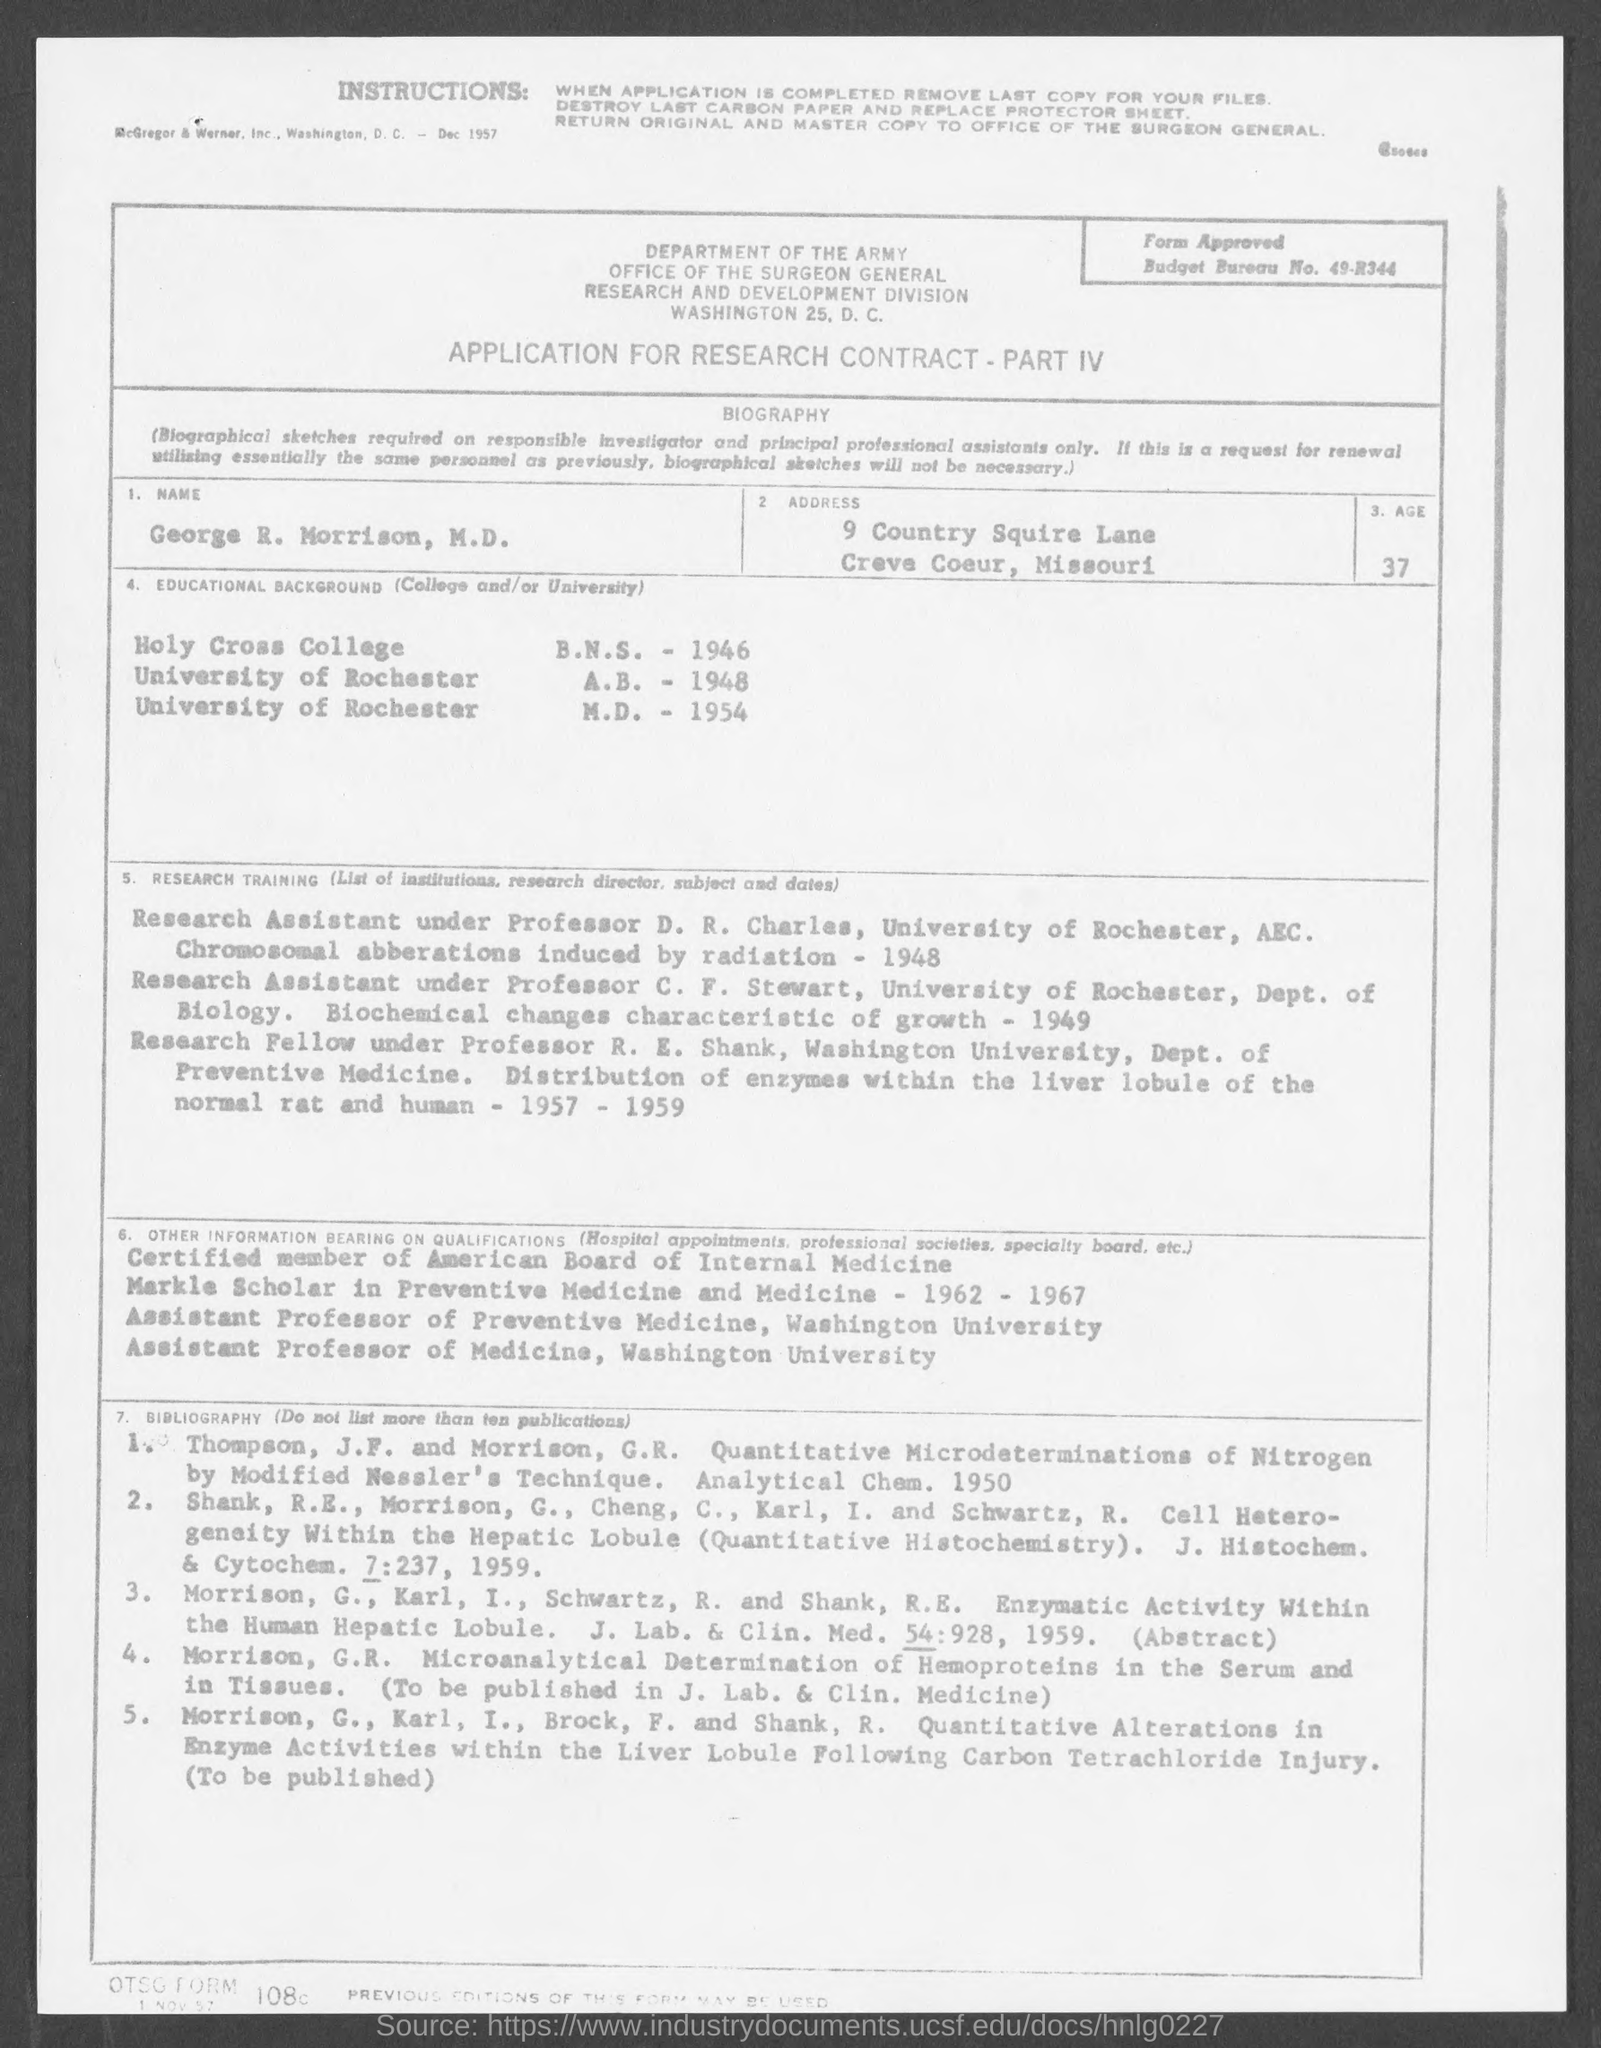Identify some key points in this picture. The form in question pertains to a research contract application. George R. Morrison received his M.D. from the University of Rochester. The name given is George R. Morrison, M.D. In 1948, George R. Morrison received his A.B. 